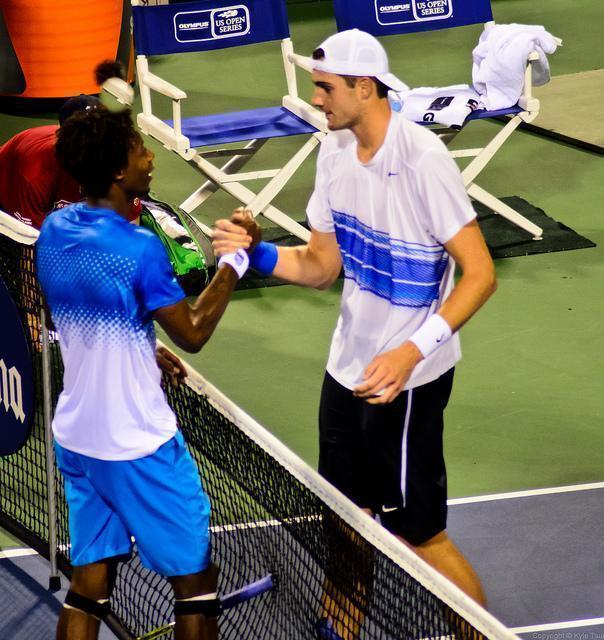Why have the two men gripped hands?
Make your selection from the four choices given to correctly answer the question.
Options: To swing, showing respect, arm wrestling, to dance. Showing respect. 